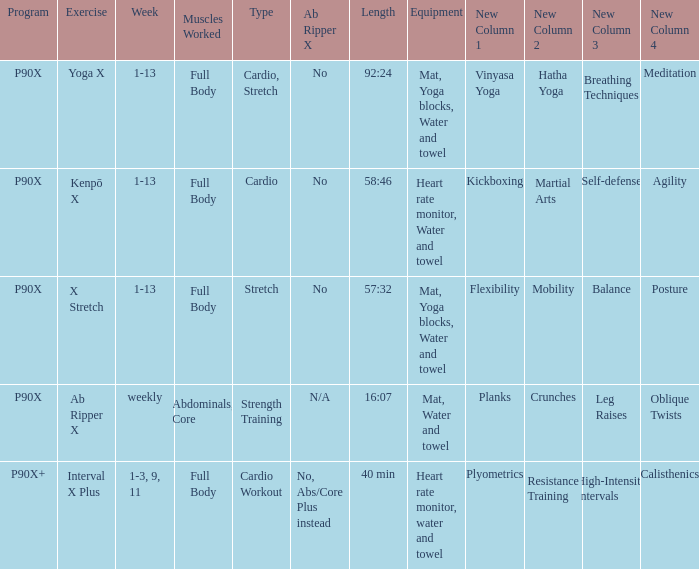What is the physical activity when the gear is heart rate monitor, water, and towel? Kenpō X, Interval X Plus. Parse the table in full. {'header': ['Program', 'Exercise', 'Week', 'Muscles Worked', 'Type', 'Ab Ripper X', 'Length', 'Equipment', 'New Column 1', 'New Column 2', 'New Column 3', 'New Column 4'], 'rows': [['P90X', 'Yoga X', '1-13', 'Full Body', 'Cardio, Stretch', 'No', '92:24', 'Mat, Yoga blocks, Water and towel', 'Vinyasa Yoga', 'Hatha Yoga', 'Breathing Techniques', 'Meditation'], ['P90X', 'Kenpō X', '1-13', 'Full Body', 'Cardio', 'No', '58:46', 'Heart rate monitor, Water and towel', 'Kickboxing', 'Martial Arts', 'Self-defense', 'Agility'], ['P90X', 'X Stretch', '1-13', 'Full Body', 'Stretch', 'No', '57:32', 'Mat, Yoga blocks, Water and towel', 'Flexibility', 'Mobility', 'Balance', 'Posture'], ['P90X', 'Ab Ripper X', 'weekly', 'Abdominals, Core', 'Strength Training', 'N/A', '16:07', 'Mat, Water and towel', 'Planks', 'Crunches', 'Leg Raises', 'Oblique Twists'], ['P90X+', 'Interval X Plus', '1-3, 9, 11', 'Full Body', 'Cardio Workout', 'No, Abs/Core Plus instead', '40 min', 'Heart rate monitor, water and towel', 'Plyometrics', 'Resistance Training', 'High-Intensity Intervals', 'Calisthenics']]} 